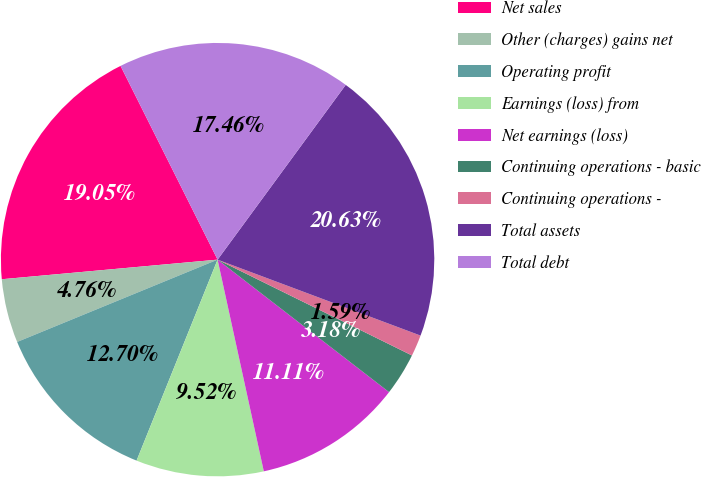<chart> <loc_0><loc_0><loc_500><loc_500><pie_chart><fcel>Net sales<fcel>Other (charges) gains net<fcel>Operating profit<fcel>Earnings (loss) from<fcel>Net earnings (loss)<fcel>Continuing operations - basic<fcel>Continuing operations -<fcel>Total assets<fcel>Total debt<nl><fcel>19.05%<fcel>4.76%<fcel>12.7%<fcel>9.52%<fcel>11.11%<fcel>3.18%<fcel>1.59%<fcel>20.63%<fcel>17.46%<nl></chart> 